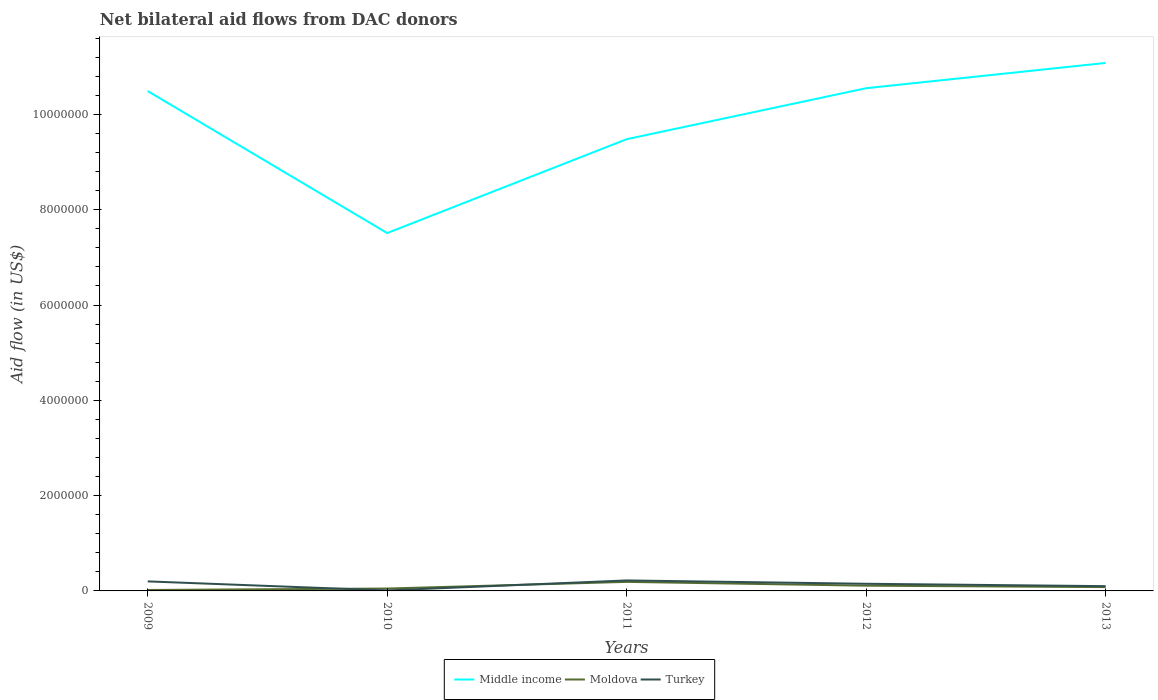How many different coloured lines are there?
Provide a succinct answer. 3. Is the number of lines equal to the number of legend labels?
Your answer should be compact. Yes. What is the difference between the highest and the second highest net bilateral aid flow in Moldova?
Keep it short and to the point. 1.70e+05. Is the net bilateral aid flow in Turkey strictly greater than the net bilateral aid flow in Moldova over the years?
Your answer should be very brief. No. How many lines are there?
Keep it short and to the point. 3. Are the values on the major ticks of Y-axis written in scientific E-notation?
Give a very brief answer. No. Does the graph contain any zero values?
Provide a succinct answer. No. How many legend labels are there?
Offer a very short reply. 3. How are the legend labels stacked?
Offer a very short reply. Horizontal. What is the title of the graph?
Keep it short and to the point. Net bilateral aid flows from DAC donors. Does "United Arab Emirates" appear as one of the legend labels in the graph?
Offer a very short reply. No. What is the label or title of the Y-axis?
Your answer should be very brief. Aid flow (in US$). What is the Aid flow (in US$) in Middle income in 2009?
Provide a short and direct response. 1.05e+07. What is the Aid flow (in US$) in Moldova in 2009?
Your response must be concise. 2.00e+04. What is the Aid flow (in US$) of Turkey in 2009?
Provide a short and direct response. 2.00e+05. What is the Aid flow (in US$) of Middle income in 2010?
Offer a terse response. 7.51e+06. What is the Aid flow (in US$) in Moldova in 2010?
Make the answer very short. 5.00e+04. What is the Aid flow (in US$) in Turkey in 2010?
Offer a terse response. 10000. What is the Aid flow (in US$) in Middle income in 2011?
Ensure brevity in your answer.  9.48e+06. What is the Aid flow (in US$) in Moldova in 2011?
Provide a short and direct response. 1.90e+05. What is the Aid flow (in US$) of Middle income in 2012?
Your response must be concise. 1.06e+07. What is the Aid flow (in US$) of Moldova in 2012?
Your answer should be compact. 1.10e+05. What is the Aid flow (in US$) in Turkey in 2012?
Provide a short and direct response. 1.50e+05. What is the Aid flow (in US$) in Middle income in 2013?
Give a very brief answer. 1.11e+07. What is the Aid flow (in US$) in Moldova in 2013?
Your answer should be very brief. 8.00e+04. What is the Aid flow (in US$) of Turkey in 2013?
Give a very brief answer. 1.00e+05. Across all years, what is the maximum Aid flow (in US$) in Middle income?
Offer a very short reply. 1.11e+07. Across all years, what is the minimum Aid flow (in US$) in Middle income?
Offer a terse response. 7.51e+06. What is the total Aid flow (in US$) in Middle income in the graph?
Keep it short and to the point. 4.91e+07. What is the total Aid flow (in US$) in Turkey in the graph?
Offer a very short reply. 6.80e+05. What is the difference between the Aid flow (in US$) in Middle income in 2009 and that in 2010?
Provide a succinct answer. 2.98e+06. What is the difference between the Aid flow (in US$) of Turkey in 2009 and that in 2010?
Your response must be concise. 1.90e+05. What is the difference between the Aid flow (in US$) in Middle income in 2009 and that in 2011?
Make the answer very short. 1.01e+06. What is the difference between the Aid flow (in US$) of Moldova in 2009 and that in 2011?
Provide a succinct answer. -1.70e+05. What is the difference between the Aid flow (in US$) in Turkey in 2009 and that in 2011?
Keep it short and to the point. -2.00e+04. What is the difference between the Aid flow (in US$) of Middle income in 2009 and that in 2012?
Keep it short and to the point. -6.00e+04. What is the difference between the Aid flow (in US$) in Moldova in 2009 and that in 2012?
Your answer should be very brief. -9.00e+04. What is the difference between the Aid flow (in US$) of Middle income in 2009 and that in 2013?
Provide a succinct answer. -5.90e+05. What is the difference between the Aid flow (in US$) in Middle income in 2010 and that in 2011?
Offer a very short reply. -1.97e+06. What is the difference between the Aid flow (in US$) of Turkey in 2010 and that in 2011?
Your answer should be compact. -2.10e+05. What is the difference between the Aid flow (in US$) in Middle income in 2010 and that in 2012?
Ensure brevity in your answer.  -3.04e+06. What is the difference between the Aid flow (in US$) of Middle income in 2010 and that in 2013?
Ensure brevity in your answer.  -3.57e+06. What is the difference between the Aid flow (in US$) in Middle income in 2011 and that in 2012?
Ensure brevity in your answer.  -1.07e+06. What is the difference between the Aid flow (in US$) of Middle income in 2011 and that in 2013?
Keep it short and to the point. -1.60e+06. What is the difference between the Aid flow (in US$) of Turkey in 2011 and that in 2013?
Keep it short and to the point. 1.20e+05. What is the difference between the Aid flow (in US$) of Middle income in 2012 and that in 2013?
Offer a terse response. -5.30e+05. What is the difference between the Aid flow (in US$) in Middle income in 2009 and the Aid flow (in US$) in Moldova in 2010?
Your answer should be very brief. 1.04e+07. What is the difference between the Aid flow (in US$) of Middle income in 2009 and the Aid flow (in US$) of Turkey in 2010?
Give a very brief answer. 1.05e+07. What is the difference between the Aid flow (in US$) of Moldova in 2009 and the Aid flow (in US$) of Turkey in 2010?
Your answer should be very brief. 10000. What is the difference between the Aid flow (in US$) in Middle income in 2009 and the Aid flow (in US$) in Moldova in 2011?
Ensure brevity in your answer.  1.03e+07. What is the difference between the Aid flow (in US$) of Middle income in 2009 and the Aid flow (in US$) of Turkey in 2011?
Make the answer very short. 1.03e+07. What is the difference between the Aid flow (in US$) of Moldova in 2009 and the Aid flow (in US$) of Turkey in 2011?
Provide a short and direct response. -2.00e+05. What is the difference between the Aid flow (in US$) in Middle income in 2009 and the Aid flow (in US$) in Moldova in 2012?
Keep it short and to the point. 1.04e+07. What is the difference between the Aid flow (in US$) of Middle income in 2009 and the Aid flow (in US$) of Turkey in 2012?
Make the answer very short. 1.03e+07. What is the difference between the Aid flow (in US$) of Moldova in 2009 and the Aid flow (in US$) of Turkey in 2012?
Your response must be concise. -1.30e+05. What is the difference between the Aid flow (in US$) of Middle income in 2009 and the Aid flow (in US$) of Moldova in 2013?
Give a very brief answer. 1.04e+07. What is the difference between the Aid flow (in US$) of Middle income in 2009 and the Aid flow (in US$) of Turkey in 2013?
Provide a succinct answer. 1.04e+07. What is the difference between the Aid flow (in US$) in Moldova in 2009 and the Aid flow (in US$) in Turkey in 2013?
Your answer should be very brief. -8.00e+04. What is the difference between the Aid flow (in US$) of Middle income in 2010 and the Aid flow (in US$) of Moldova in 2011?
Keep it short and to the point. 7.32e+06. What is the difference between the Aid flow (in US$) in Middle income in 2010 and the Aid flow (in US$) in Turkey in 2011?
Offer a terse response. 7.29e+06. What is the difference between the Aid flow (in US$) in Moldova in 2010 and the Aid flow (in US$) in Turkey in 2011?
Ensure brevity in your answer.  -1.70e+05. What is the difference between the Aid flow (in US$) in Middle income in 2010 and the Aid flow (in US$) in Moldova in 2012?
Give a very brief answer. 7.40e+06. What is the difference between the Aid flow (in US$) of Middle income in 2010 and the Aid flow (in US$) of Turkey in 2012?
Your answer should be compact. 7.36e+06. What is the difference between the Aid flow (in US$) of Middle income in 2010 and the Aid flow (in US$) of Moldova in 2013?
Keep it short and to the point. 7.43e+06. What is the difference between the Aid flow (in US$) of Middle income in 2010 and the Aid flow (in US$) of Turkey in 2013?
Make the answer very short. 7.41e+06. What is the difference between the Aid flow (in US$) of Middle income in 2011 and the Aid flow (in US$) of Moldova in 2012?
Provide a short and direct response. 9.37e+06. What is the difference between the Aid flow (in US$) of Middle income in 2011 and the Aid flow (in US$) of Turkey in 2012?
Your answer should be compact. 9.33e+06. What is the difference between the Aid flow (in US$) of Middle income in 2011 and the Aid flow (in US$) of Moldova in 2013?
Make the answer very short. 9.40e+06. What is the difference between the Aid flow (in US$) in Middle income in 2011 and the Aid flow (in US$) in Turkey in 2013?
Ensure brevity in your answer.  9.38e+06. What is the difference between the Aid flow (in US$) of Middle income in 2012 and the Aid flow (in US$) of Moldova in 2013?
Offer a terse response. 1.05e+07. What is the difference between the Aid flow (in US$) of Middle income in 2012 and the Aid flow (in US$) of Turkey in 2013?
Give a very brief answer. 1.04e+07. What is the average Aid flow (in US$) in Middle income per year?
Provide a succinct answer. 9.82e+06. What is the average Aid flow (in US$) in Moldova per year?
Provide a succinct answer. 9.00e+04. What is the average Aid flow (in US$) of Turkey per year?
Make the answer very short. 1.36e+05. In the year 2009, what is the difference between the Aid flow (in US$) in Middle income and Aid flow (in US$) in Moldova?
Your answer should be very brief. 1.05e+07. In the year 2009, what is the difference between the Aid flow (in US$) in Middle income and Aid flow (in US$) in Turkey?
Your answer should be compact. 1.03e+07. In the year 2010, what is the difference between the Aid flow (in US$) of Middle income and Aid flow (in US$) of Moldova?
Give a very brief answer. 7.46e+06. In the year 2010, what is the difference between the Aid flow (in US$) in Middle income and Aid flow (in US$) in Turkey?
Keep it short and to the point. 7.50e+06. In the year 2010, what is the difference between the Aid flow (in US$) in Moldova and Aid flow (in US$) in Turkey?
Give a very brief answer. 4.00e+04. In the year 2011, what is the difference between the Aid flow (in US$) of Middle income and Aid flow (in US$) of Moldova?
Offer a terse response. 9.29e+06. In the year 2011, what is the difference between the Aid flow (in US$) in Middle income and Aid flow (in US$) in Turkey?
Provide a succinct answer. 9.26e+06. In the year 2012, what is the difference between the Aid flow (in US$) of Middle income and Aid flow (in US$) of Moldova?
Provide a succinct answer. 1.04e+07. In the year 2012, what is the difference between the Aid flow (in US$) of Middle income and Aid flow (in US$) of Turkey?
Ensure brevity in your answer.  1.04e+07. In the year 2013, what is the difference between the Aid flow (in US$) of Middle income and Aid flow (in US$) of Moldova?
Ensure brevity in your answer.  1.10e+07. In the year 2013, what is the difference between the Aid flow (in US$) in Middle income and Aid flow (in US$) in Turkey?
Provide a succinct answer. 1.10e+07. What is the ratio of the Aid flow (in US$) of Middle income in 2009 to that in 2010?
Make the answer very short. 1.4. What is the ratio of the Aid flow (in US$) of Moldova in 2009 to that in 2010?
Keep it short and to the point. 0.4. What is the ratio of the Aid flow (in US$) of Turkey in 2009 to that in 2010?
Keep it short and to the point. 20. What is the ratio of the Aid flow (in US$) in Middle income in 2009 to that in 2011?
Your answer should be very brief. 1.11. What is the ratio of the Aid flow (in US$) in Moldova in 2009 to that in 2011?
Your response must be concise. 0.11. What is the ratio of the Aid flow (in US$) of Turkey in 2009 to that in 2011?
Ensure brevity in your answer.  0.91. What is the ratio of the Aid flow (in US$) in Middle income in 2009 to that in 2012?
Offer a very short reply. 0.99. What is the ratio of the Aid flow (in US$) of Moldova in 2009 to that in 2012?
Keep it short and to the point. 0.18. What is the ratio of the Aid flow (in US$) of Turkey in 2009 to that in 2012?
Offer a very short reply. 1.33. What is the ratio of the Aid flow (in US$) of Middle income in 2009 to that in 2013?
Offer a terse response. 0.95. What is the ratio of the Aid flow (in US$) in Moldova in 2009 to that in 2013?
Your answer should be very brief. 0.25. What is the ratio of the Aid flow (in US$) in Turkey in 2009 to that in 2013?
Provide a succinct answer. 2. What is the ratio of the Aid flow (in US$) of Middle income in 2010 to that in 2011?
Keep it short and to the point. 0.79. What is the ratio of the Aid flow (in US$) in Moldova in 2010 to that in 2011?
Offer a terse response. 0.26. What is the ratio of the Aid flow (in US$) in Turkey in 2010 to that in 2011?
Give a very brief answer. 0.05. What is the ratio of the Aid flow (in US$) of Middle income in 2010 to that in 2012?
Ensure brevity in your answer.  0.71. What is the ratio of the Aid flow (in US$) in Moldova in 2010 to that in 2012?
Your response must be concise. 0.45. What is the ratio of the Aid flow (in US$) of Turkey in 2010 to that in 2012?
Your answer should be very brief. 0.07. What is the ratio of the Aid flow (in US$) in Middle income in 2010 to that in 2013?
Provide a succinct answer. 0.68. What is the ratio of the Aid flow (in US$) of Moldova in 2010 to that in 2013?
Keep it short and to the point. 0.62. What is the ratio of the Aid flow (in US$) of Turkey in 2010 to that in 2013?
Ensure brevity in your answer.  0.1. What is the ratio of the Aid flow (in US$) in Middle income in 2011 to that in 2012?
Offer a terse response. 0.9. What is the ratio of the Aid flow (in US$) of Moldova in 2011 to that in 2012?
Provide a succinct answer. 1.73. What is the ratio of the Aid flow (in US$) in Turkey in 2011 to that in 2012?
Make the answer very short. 1.47. What is the ratio of the Aid flow (in US$) of Middle income in 2011 to that in 2013?
Give a very brief answer. 0.86. What is the ratio of the Aid flow (in US$) of Moldova in 2011 to that in 2013?
Ensure brevity in your answer.  2.38. What is the ratio of the Aid flow (in US$) of Middle income in 2012 to that in 2013?
Keep it short and to the point. 0.95. What is the ratio of the Aid flow (in US$) of Moldova in 2012 to that in 2013?
Give a very brief answer. 1.38. What is the ratio of the Aid flow (in US$) of Turkey in 2012 to that in 2013?
Ensure brevity in your answer.  1.5. What is the difference between the highest and the second highest Aid flow (in US$) in Middle income?
Keep it short and to the point. 5.30e+05. What is the difference between the highest and the second highest Aid flow (in US$) of Turkey?
Offer a terse response. 2.00e+04. What is the difference between the highest and the lowest Aid flow (in US$) in Middle income?
Keep it short and to the point. 3.57e+06. What is the difference between the highest and the lowest Aid flow (in US$) in Moldova?
Your response must be concise. 1.70e+05. What is the difference between the highest and the lowest Aid flow (in US$) of Turkey?
Give a very brief answer. 2.10e+05. 